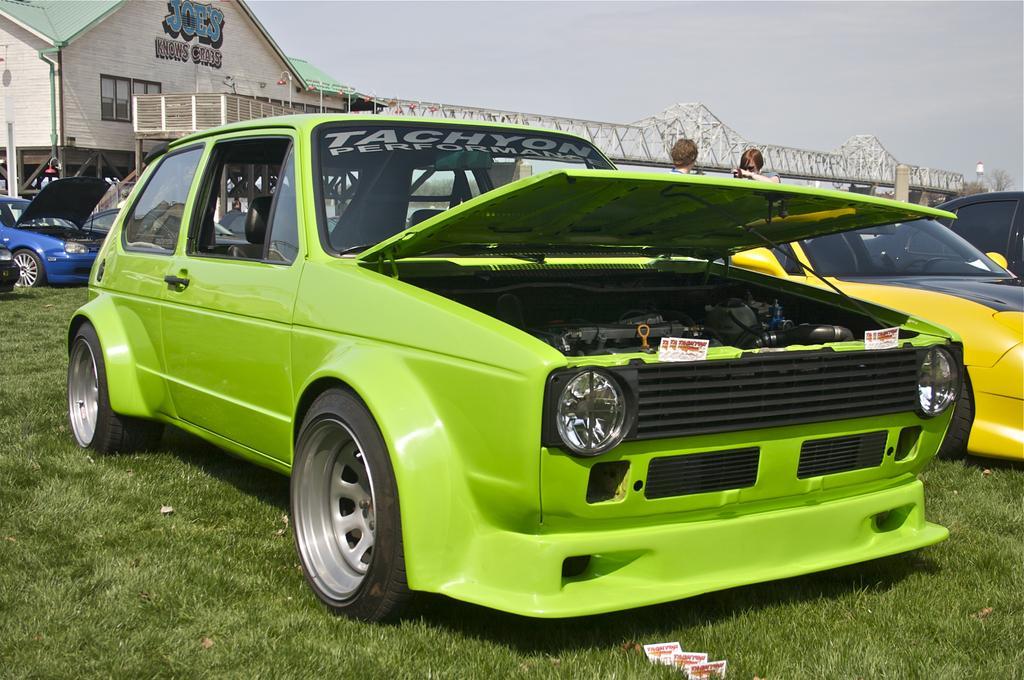In one or two sentences, can you explain what this image depicts? In this picture we can see few people and cars on the grass, in the background we can see a building, few trees and a bridge. 